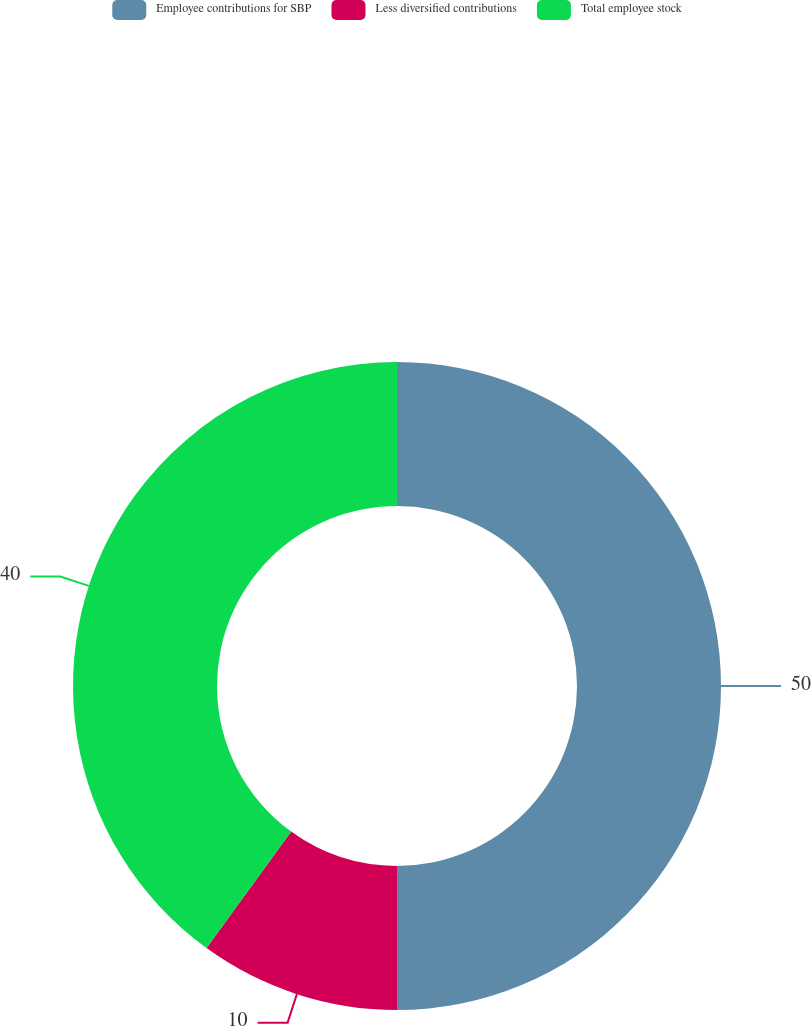Convert chart to OTSL. <chart><loc_0><loc_0><loc_500><loc_500><pie_chart><fcel>Employee contributions for SBP<fcel>Less diversified contributions<fcel>Total employee stock<nl><fcel>50.0%<fcel>10.0%<fcel>40.0%<nl></chart> 